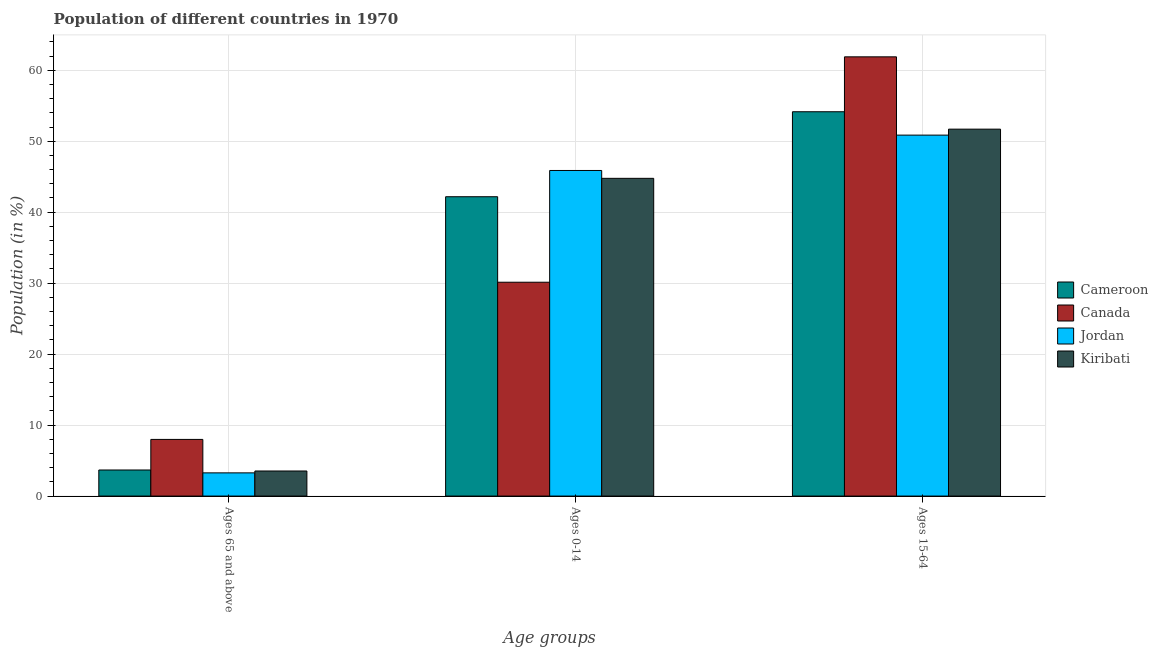How many groups of bars are there?
Make the answer very short. 3. Are the number of bars per tick equal to the number of legend labels?
Offer a terse response. Yes. Are the number of bars on each tick of the X-axis equal?
Your answer should be compact. Yes. How many bars are there on the 2nd tick from the left?
Give a very brief answer. 4. What is the label of the 2nd group of bars from the left?
Provide a short and direct response. Ages 0-14. What is the percentage of population within the age-group of 65 and above in Jordan?
Ensure brevity in your answer.  3.27. Across all countries, what is the maximum percentage of population within the age-group 0-14?
Make the answer very short. 45.88. Across all countries, what is the minimum percentage of population within the age-group 15-64?
Offer a very short reply. 50.86. In which country was the percentage of population within the age-group 0-14 maximum?
Ensure brevity in your answer.  Jordan. In which country was the percentage of population within the age-group 15-64 minimum?
Ensure brevity in your answer.  Jordan. What is the total percentage of population within the age-group of 65 and above in the graph?
Your answer should be compact. 18.46. What is the difference between the percentage of population within the age-group 0-14 in Kiribati and that in Cameroon?
Provide a short and direct response. 2.59. What is the difference between the percentage of population within the age-group of 65 and above in Canada and the percentage of population within the age-group 0-14 in Kiribati?
Make the answer very short. -36.79. What is the average percentage of population within the age-group 0-14 per country?
Ensure brevity in your answer.  40.74. What is the difference between the percentage of population within the age-group 15-64 and percentage of population within the age-group 0-14 in Canada?
Ensure brevity in your answer.  31.76. What is the ratio of the percentage of population within the age-group 0-14 in Canada to that in Jordan?
Offer a very short reply. 0.66. Is the percentage of population within the age-group 15-64 in Cameroon less than that in Jordan?
Your response must be concise. No. What is the difference between the highest and the second highest percentage of population within the age-group of 65 and above?
Keep it short and to the point. 4.31. What is the difference between the highest and the lowest percentage of population within the age-group of 65 and above?
Offer a terse response. 4.71. What does the 4th bar from the left in Ages 0-14 represents?
Your answer should be very brief. Kiribati. How many bars are there?
Make the answer very short. 12. Are all the bars in the graph horizontal?
Make the answer very short. No. Are the values on the major ticks of Y-axis written in scientific E-notation?
Provide a succinct answer. No. Does the graph contain any zero values?
Your answer should be very brief. No. How many legend labels are there?
Make the answer very short. 4. How are the legend labels stacked?
Ensure brevity in your answer.  Vertical. What is the title of the graph?
Give a very brief answer. Population of different countries in 1970. Does "Japan" appear as one of the legend labels in the graph?
Offer a terse response. No. What is the label or title of the X-axis?
Your answer should be compact. Age groups. What is the label or title of the Y-axis?
Your response must be concise. Population (in %). What is the Population (in %) of Cameroon in Ages 65 and above?
Provide a short and direct response. 3.67. What is the Population (in %) in Canada in Ages 65 and above?
Provide a succinct answer. 7.98. What is the Population (in %) of Jordan in Ages 65 and above?
Make the answer very short. 3.27. What is the Population (in %) of Kiribati in Ages 65 and above?
Offer a very short reply. 3.53. What is the Population (in %) in Cameroon in Ages 0-14?
Ensure brevity in your answer.  42.18. What is the Population (in %) of Canada in Ages 0-14?
Your response must be concise. 30.13. What is the Population (in %) in Jordan in Ages 0-14?
Your answer should be very brief. 45.88. What is the Population (in %) of Kiribati in Ages 0-14?
Your response must be concise. 44.77. What is the Population (in %) of Cameroon in Ages 15-64?
Your answer should be very brief. 54.15. What is the Population (in %) in Canada in Ages 15-64?
Your answer should be very brief. 61.89. What is the Population (in %) of Jordan in Ages 15-64?
Give a very brief answer. 50.86. What is the Population (in %) in Kiribati in Ages 15-64?
Your answer should be very brief. 51.7. Across all Age groups, what is the maximum Population (in %) of Cameroon?
Make the answer very short. 54.15. Across all Age groups, what is the maximum Population (in %) in Canada?
Keep it short and to the point. 61.89. Across all Age groups, what is the maximum Population (in %) in Jordan?
Your response must be concise. 50.86. Across all Age groups, what is the maximum Population (in %) in Kiribati?
Make the answer very short. 51.7. Across all Age groups, what is the minimum Population (in %) in Cameroon?
Your response must be concise. 3.67. Across all Age groups, what is the minimum Population (in %) in Canada?
Keep it short and to the point. 7.98. Across all Age groups, what is the minimum Population (in %) in Jordan?
Your answer should be compact. 3.27. Across all Age groups, what is the minimum Population (in %) in Kiribati?
Your answer should be very brief. 3.53. What is the total Population (in %) in Canada in the graph?
Your response must be concise. 100. What is the total Population (in %) of Jordan in the graph?
Your response must be concise. 100. What is the total Population (in %) of Kiribati in the graph?
Provide a short and direct response. 100. What is the difference between the Population (in %) in Cameroon in Ages 65 and above and that in Ages 0-14?
Offer a terse response. -38.5. What is the difference between the Population (in %) in Canada in Ages 65 and above and that in Ages 0-14?
Give a very brief answer. -22.15. What is the difference between the Population (in %) in Jordan in Ages 65 and above and that in Ages 0-14?
Your answer should be very brief. -42.61. What is the difference between the Population (in %) in Kiribati in Ages 65 and above and that in Ages 0-14?
Give a very brief answer. -41.24. What is the difference between the Population (in %) of Cameroon in Ages 65 and above and that in Ages 15-64?
Your answer should be very brief. -50.48. What is the difference between the Population (in %) of Canada in Ages 65 and above and that in Ages 15-64?
Provide a short and direct response. -53.9. What is the difference between the Population (in %) in Jordan in Ages 65 and above and that in Ages 15-64?
Your answer should be very brief. -47.59. What is the difference between the Population (in %) in Kiribati in Ages 65 and above and that in Ages 15-64?
Your answer should be compact. -48.17. What is the difference between the Population (in %) of Cameroon in Ages 0-14 and that in Ages 15-64?
Offer a very short reply. -11.97. What is the difference between the Population (in %) in Canada in Ages 0-14 and that in Ages 15-64?
Your response must be concise. -31.76. What is the difference between the Population (in %) in Jordan in Ages 0-14 and that in Ages 15-64?
Give a very brief answer. -4.98. What is the difference between the Population (in %) in Kiribati in Ages 0-14 and that in Ages 15-64?
Provide a short and direct response. -6.93. What is the difference between the Population (in %) of Cameroon in Ages 65 and above and the Population (in %) of Canada in Ages 0-14?
Your answer should be very brief. -26.46. What is the difference between the Population (in %) in Cameroon in Ages 65 and above and the Population (in %) in Jordan in Ages 0-14?
Offer a very short reply. -42.2. What is the difference between the Population (in %) of Cameroon in Ages 65 and above and the Population (in %) of Kiribati in Ages 0-14?
Your response must be concise. -41.09. What is the difference between the Population (in %) of Canada in Ages 65 and above and the Population (in %) of Jordan in Ages 0-14?
Your answer should be compact. -37.89. What is the difference between the Population (in %) of Canada in Ages 65 and above and the Population (in %) of Kiribati in Ages 0-14?
Keep it short and to the point. -36.79. What is the difference between the Population (in %) in Jordan in Ages 65 and above and the Population (in %) in Kiribati in Ages 0-14?
Provide a succinct answer. -41.5. What is the difference between the Population (in %) of Cameroon in Ages 65 and above and the Population (in %) of Canada in Ages 15-64?
Your response must be concise. -58.21. What is the difference between the Population (in %) of Cameroon in Ages 65 and above and the Population (in %) of Jordan in Ages 15-64?
Keep it short and to the point. -47.18. What is the difference between the Population (in %) in Cameroon in Ages 65 and above and the Population (in %) in Kiribati in Ages 15-64?
Provide a succinct answer. -48.02. What is the difference between the Population (in %) of Canada in Ages 65 and above and the Population (in %) of Jordan in Ages 15-64?
Offer a very short reply. -42.87. What is the difference between the Population (in %) in Canada in Ages 65 and above and the Population (in %) in Kiribati in Ages 15-64?
Ensure brevity in your answer.  -43.72. What is the difference between the Population (in %) in Jordan in Ages 65 and above and the Population (in %) in Kiribati in Ages 15-64?
Your answer should be compact. -48.43. What is the difference between the Population (in %) in Cameroon in Ages 0-14 and the Population (in %) in Canada in Ages 15-64?
Your response must be concise. -19.71. What is the difference between the Population (in %) of Cameroon in Ages 0-14 and the Population (in %) of Jordan in Ages 15-64?
Your answer should be very brief. -8.68. What is the difference between the Population (in %) in Cameroon in Ages 0-14 and the Population (in %) in Kiribati in Ages 15-64?
Ensure brevity in your answer.  -9.52. What is the difference between the Population (in %) of Canada in Ages 0-14 and the Population (in %) of Jordan in Ages 15-64?
Make the answer very short. -20.73. What is the difference between the Population (in %) in Canada in Ages 0-14 and the Population (in %) in Kiribati in Ages 15-64?
Provide a short and direct response. -21.57. What is the difference between the Population (in %) of Jordan in Ages 0-14 and the Population (in %) of Kiribati in Ages 15-64?
Make the answer very short. -5.82. What is the average Population (in %) in Cameroon per Age groups?
Your answer should be very brief. 33.33. What is the average Population (in %) in Canada per Age groups?
Ensure brevity in your answer.  33.33. What is the average Population (in %) in Jordan per Age groups?
Your answer should be very brief. 33.33. What is the average Population (in %) of Kiribati per Age groups?
Offer a terse response. 33.33. What is the difference between the Population (in %) in Cameroon and Population (in %) in Canada in Ages 65 and above?
Provide a succinct answer. -4.31. What is the difference between the Population (in %) of Cameroon and Population (in %) of Jordan in Ages 65 and above?
Provide a succinct answer. 0.41. What is the difference between the Population (in %) of Cameroon and Population (in %) of Kiribati in Ages 65 and above?
Give a very brief answer. 0.14. What is the difference between the Population (in %) of Canada and Population (in %) of Jordan in Ages 65 and above?
Offer a very short reply. 4.71. What is the difference between the Population (in %) of Canada and Population (in %) of Kiribati in Ages 65 and above?
Provide a short and direct response. 4.45. What is the difference between the Population (in %) in Jordan and Population (in %) in Kiribati in Ages 65 and above?
Give a very brief answer. -0.26. What is the difference between the Population (in %) of Cameroon and Population (in %) of Canada in Ages 0-14?
Your response must be concise. 12.05. What is the difference between the Population (in %) of Cameroon and Population (in %) of Jordan in Ages 0-14?
Your response must be concise. -3.7. What is the difference between the Population (in %) in Cameroon and Population (in %) in Kiribati in Ages 0-14?
Keep it short and to the point. -2.59. What is the difference between the Population (in %) of Canada and Population (in %) of Jordan in Ages 0-14?
Your answer should be very brief. -15.75. What is the difference between the Population (in %) in Canada and Population (in %) in Kiribati in Ages 0-14?
Offer a terse response. -14.64. What is the difference between the Population (in %) of Jordan and Population (in %) of Kiribati in Ages 0-14?
Give a very brief answer. 1.11. What is the difference between the Population (in %) in Cameroon and Population (in %) in Canada in Ages 15-64?
Your answer should be compact. -7.74. What is the difference between the Population (in %) in Cameroon and Population (in %) in Jordan in Ages 15-64?
Your answer should be very brief. 3.29. What is the difference between the Population (in %) in Cameroon and Population (in %) in Kiribati in Ages 15-64?
Your answer should be compact. 2.45. What is the difference between the Population (in %) in Canada and Population (in %) in Jordan in Ages 15-64?
Provide a succinct answer. 11.03. What is the difference between the Population (in %) of Canada and Population (in %) of Kiribati in Ages 15-64?
Your answer should be very brief. 10.19. What is the difference between the Population (in %) of Jordan and Population (in %) of Kiribati in Ages 15-64?
Give a very brief answer. -0.84. What is the ratio of the Population (in %) of Cameroon in Ages 65 and above to that in Ages 0-14?
Your answer should be very brief. 0.09. What is the ratio of the Population (in %) of Canada in Ages 65 and above to that in Ages 0-14?
Ensure brevity in your answer.  0.27. What is the ratio of the Population (in %) in Jordan in Ages 65 and above to that in Ages 0-14?
Give a very brief answer. 0.07. What is the ratio of the Population (in %) of Kiribati in Ages 65 and above to that in Ages 0-14?
Your answer should be compact. 0.08. What is the ratio of the Population (in %) of Cameroon in Ages 65 and above to that in Ages 15-64?
Ensure brevity in your answer.  0.07. What is the ratio of the Population (in %) of Canada in Ages 65 and above to that in Ages 15-64?
Offer a very short reply. 0.13. What is the ratio of the Population (in %) of Jordan in Ages 65 and above to that in Ages 15-64?
Your response must be concise. 0.06. What is the ratio of the Population (in %) in Kiribati in Ages 65 and above to that in Ages 15-64?
Your answer should be compact. 0.07. What is the ratio of the Population (in %) in Cameroon in Ages 0-14 to that in Ages 15-64?
Your response must be concise. 0.78. What is the ratio of the Population (in %) of Canada in Ages 0-14 to that in Ages 15-64?
Your response must be concise. 0.49. What is the ratio of the Population (in %) in Jordan in Ages 0-14 to that in Ages 15-64?
Your answer should be compact. 0.9. What is the ratio of the Population (in %) in Kiribati in Ages 0-14 to that in Ages 15-64?
Ensure brevity in your answer.  0.87. What is the difference between the highest and the second highest Population (in %) of Cameroon?
Keep it short and to the point. 11.97. What is the difference between the highest and the second highest Population (in %) of Canada?
Offer a terse response. 31.76. What is the difference between the highest and the second highest Population (in %) of Jordan?
Ensure brevity in your answer.  4.98. What is the difference between the highest and the second highest Population (in %) in Kiribati?
Ensure brevity in your answer.  6.93. What is the difference between the highest and the lowest Population (in %) in Cameroon?
Provide a succinct answer. 50.48. What is the difference between the highest and the lowest Population (in %) in Canada?
Provide a short and direct response. 53.9. What is the difference between the highest and the lowest Population (in %) in Jordan?
Your answer should be very brief. 47.59. What is the difference between the highest and the lowest Population (in %) in Kiribati?
Keep it short and to the point. 48.17. 